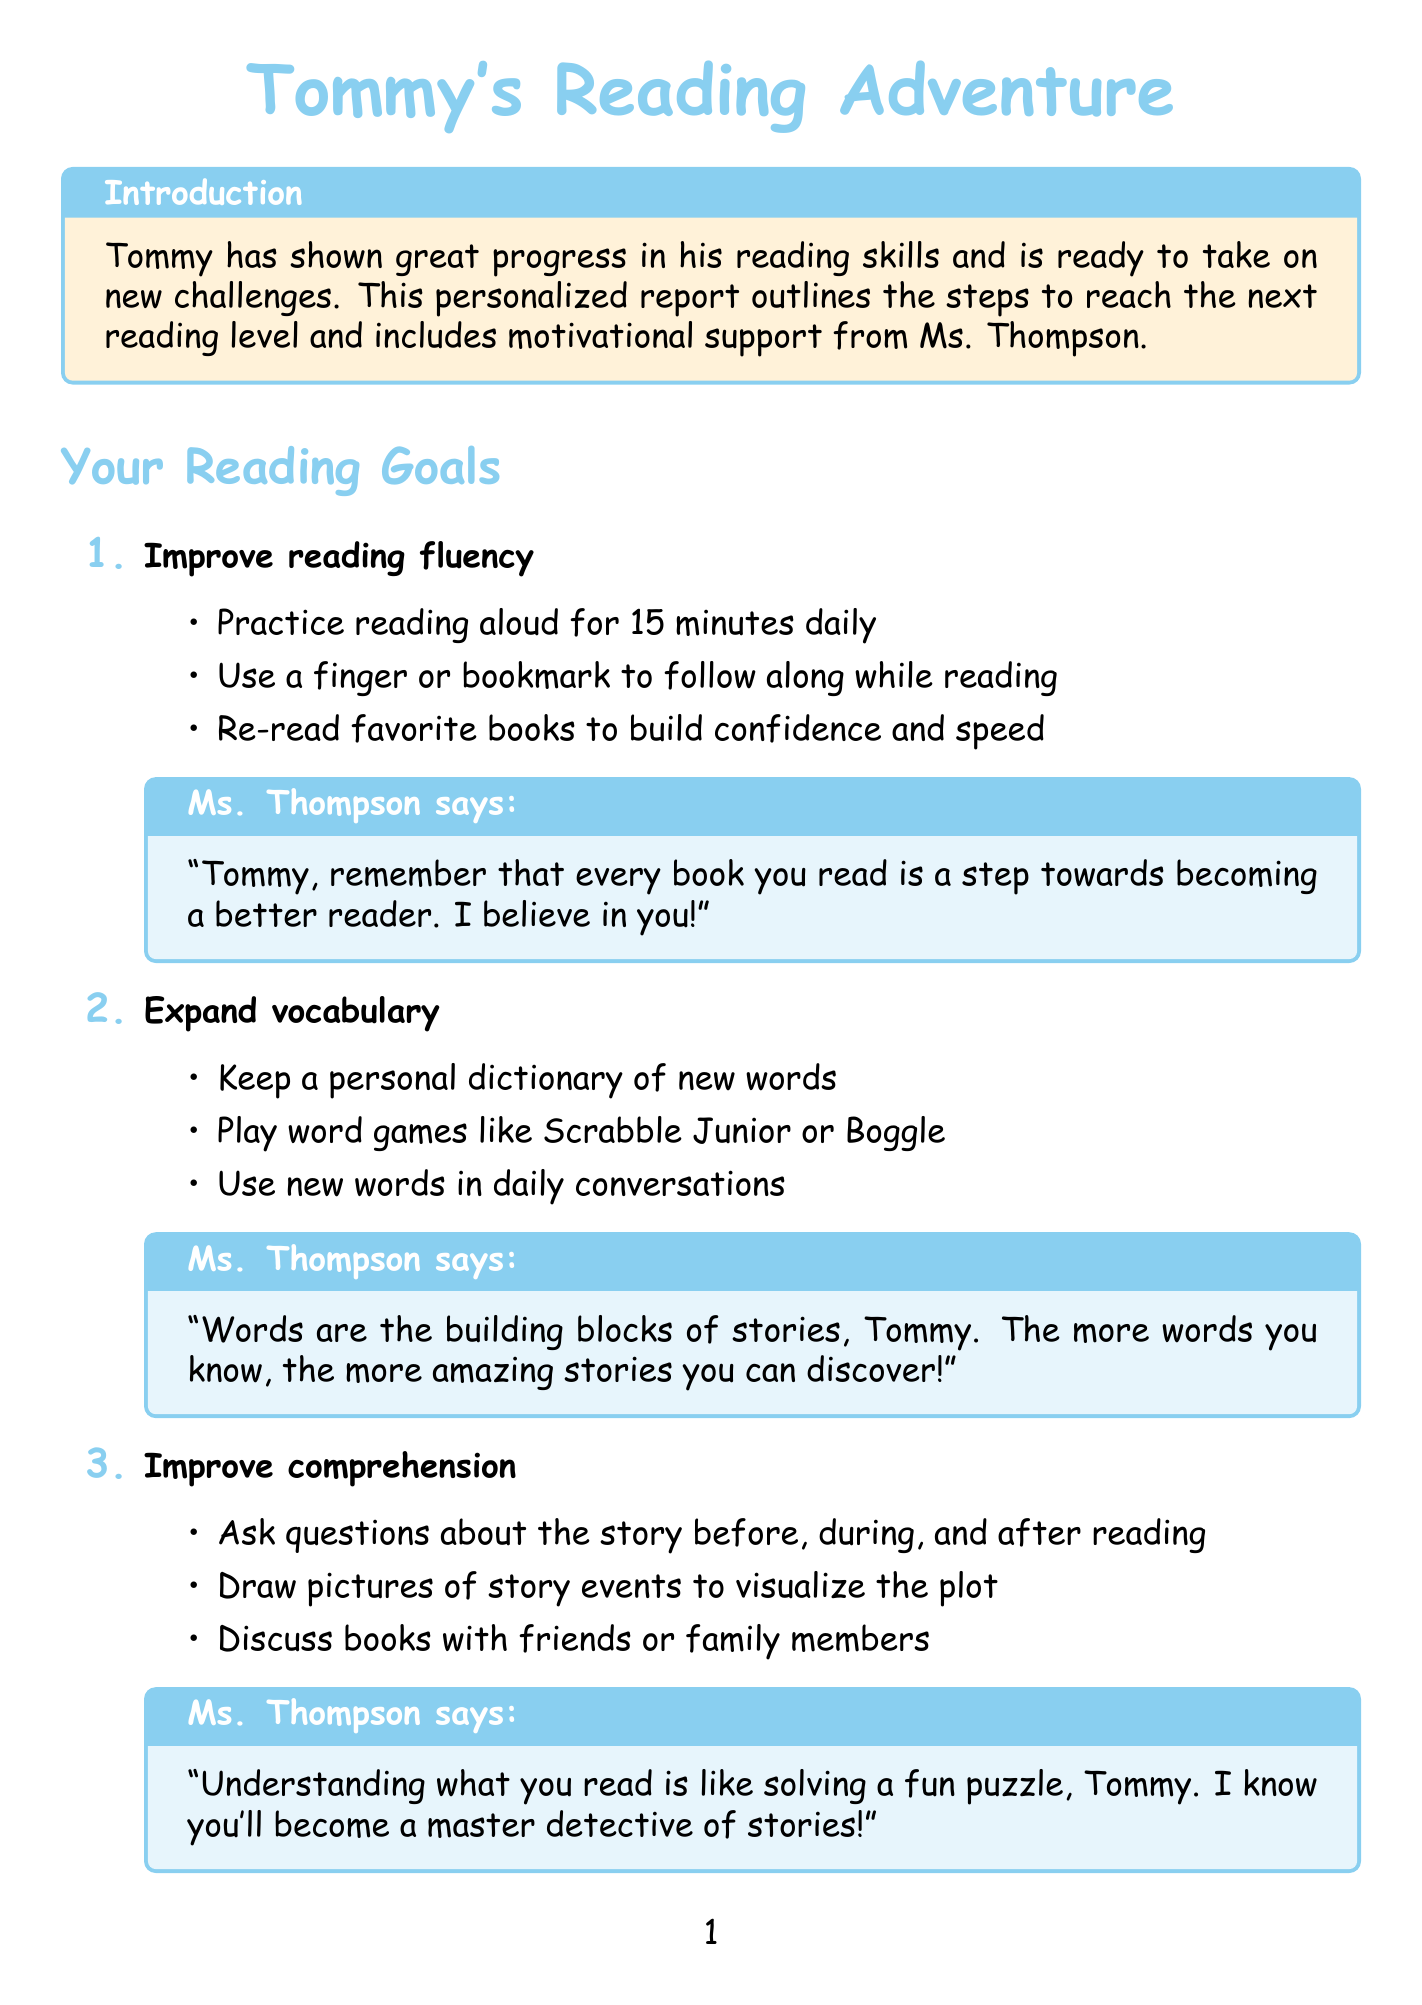what is Tommy's current reading level? The document states that Tommy's current reading level is "2nd grade."
Answer: 2nd grade what is Tommy's target reading level? The report indicates that Tommy's target reading level is "3rd grade."
Answer: 3rd grade who is the reading specialist? The document mentions Ms. Sarah Thompson as the reading specialist.
Answer: Ms. Sarah Thompson how many goals are outlined in the report? There are three goals outlined in Tommy's reading report.
Answer: 3 what is one strategy to improve reading fluency? The document lists "Practice reading aloud for 15 minutes daily" as a strategy to improve reading fluency.
Answer: Practice reading aloud for 15 minutes daily what type of log is used for progress tracking? The report states that a "Reading Log" is used to track progress.
Answer: Reading Log how often will Tommy's progress be reviewed? The document specifies that Tommy's progress will be reviewed "every two weeks."
Answer: every two weeks what is the milestone for the reward system? The report indicates that the milestone is "For every 5 books completed."
Answer: For every 5 books completed what is one book recommended for Tommy? The document recommends "Charlotte's Web" by E.B. White as a book for Tommy.
Answer: Charlotte's Web what motivational quote does Ms. Thompson use at the end? The document quotes "Believe you can, and you're halfway there. I believe in you, Tommy!" at the end.
Answer: Believe you can, and you're halfway there. I believe in you, Tommy! 